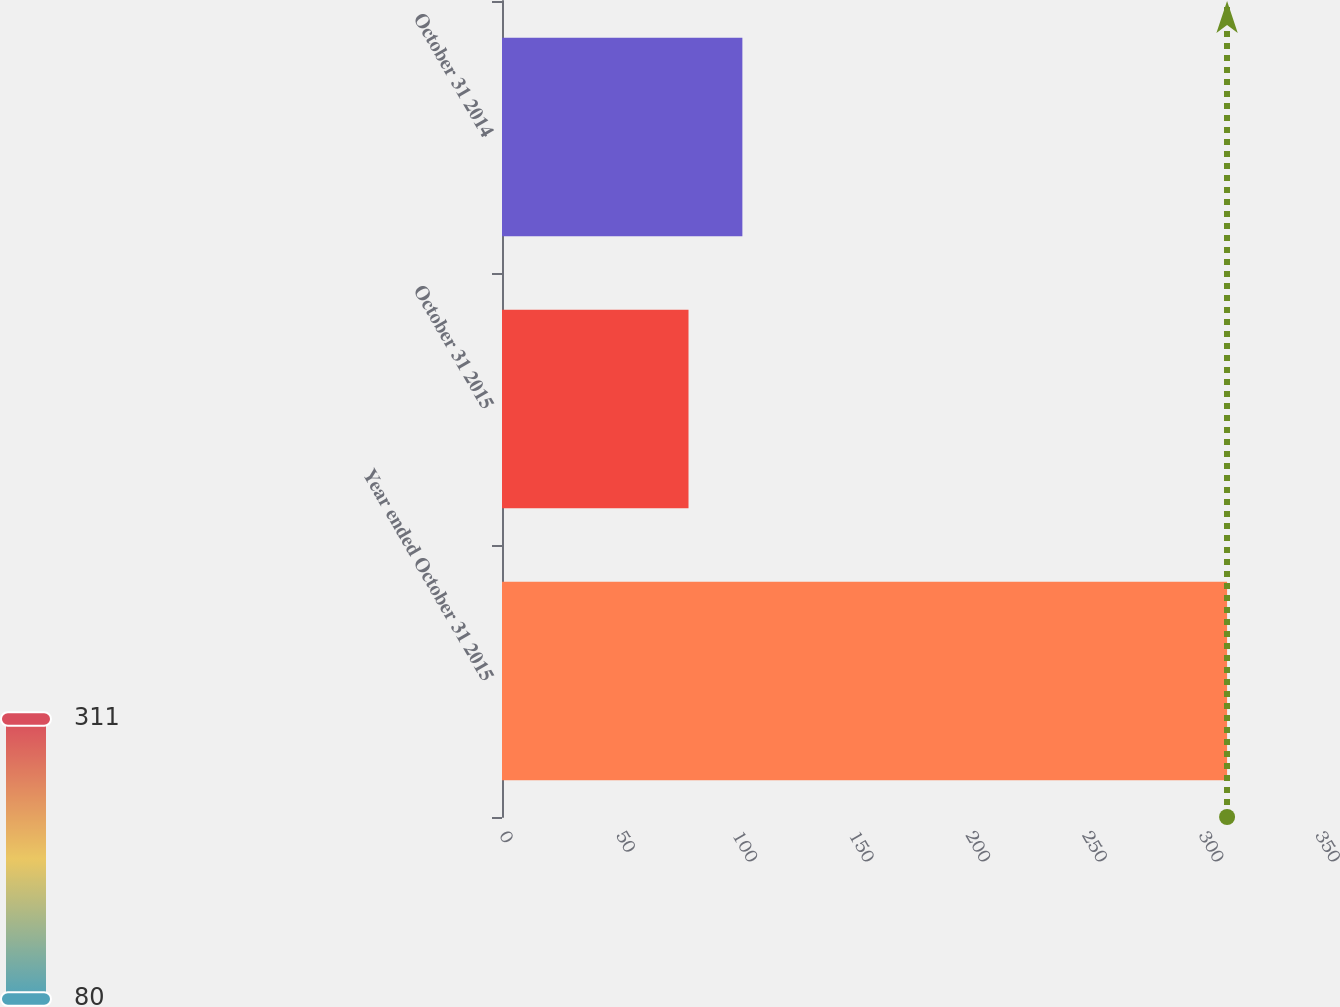Convert chart. <chart><loc_0><loc_0><loc_500><loc_500><bar_chart><fcel>Year ended October 31 2015<fcel>October 31 2015<fcel>October 31 2014<nl><fcel>311<fcel>80<fcel>103.1<nl></chart> 